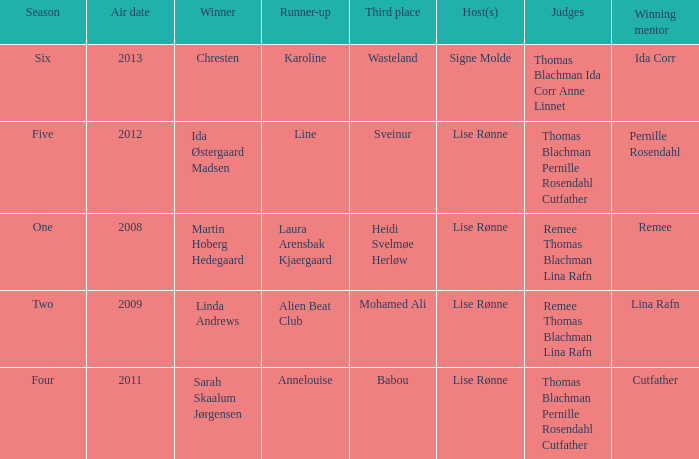Who was the runner-up in season five? Line. 